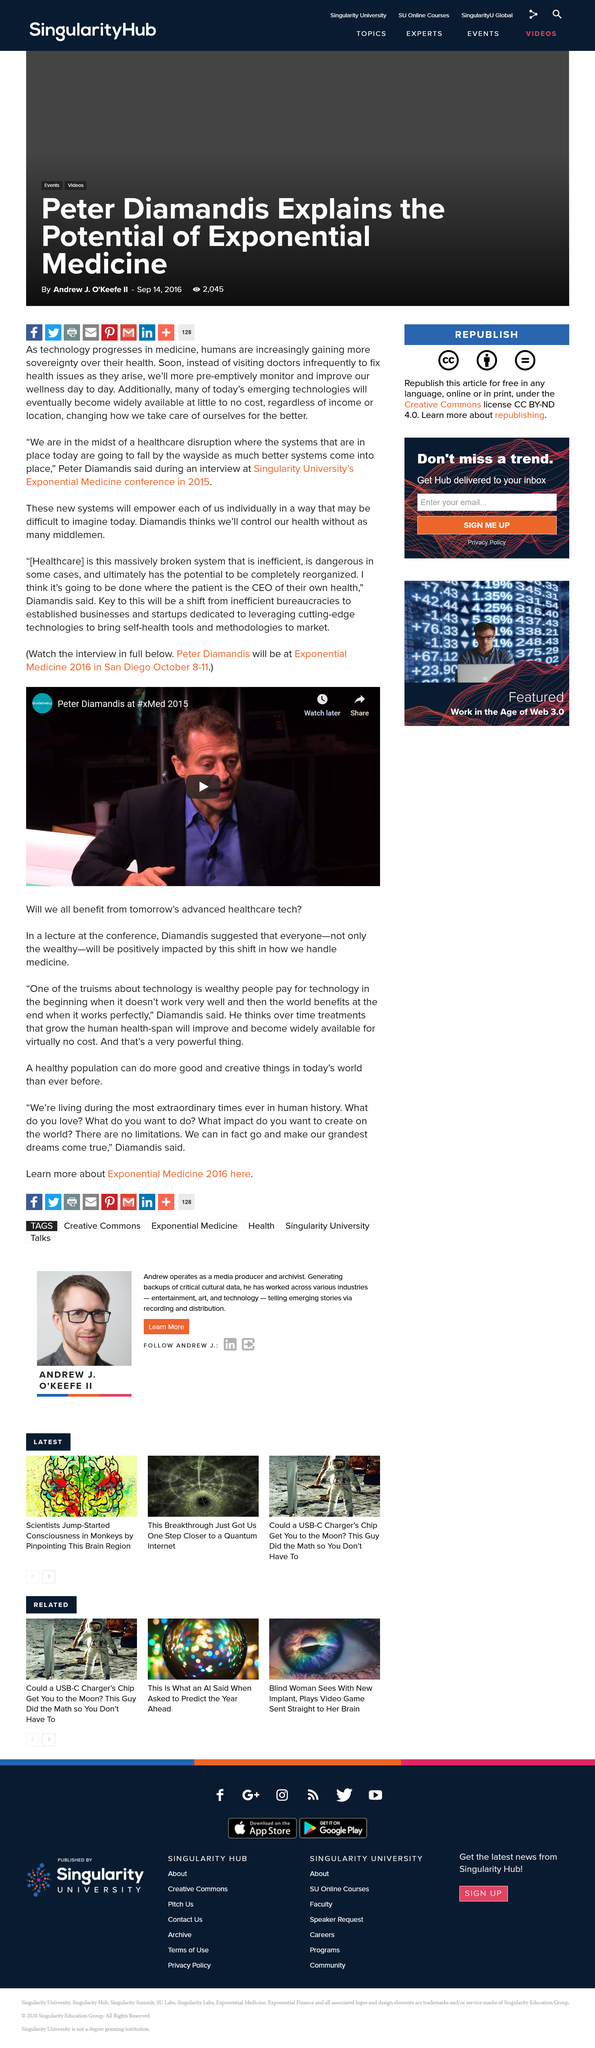Indicate a few pertinent items in this graphic. When was xMed 2015 held? The speaker is declaring that Peter Diamandis is who they are referring to as "him". The advanced healthcare technology has a positive impact on the way we handle medicine and this shift will continue to benefit the field in the future. 